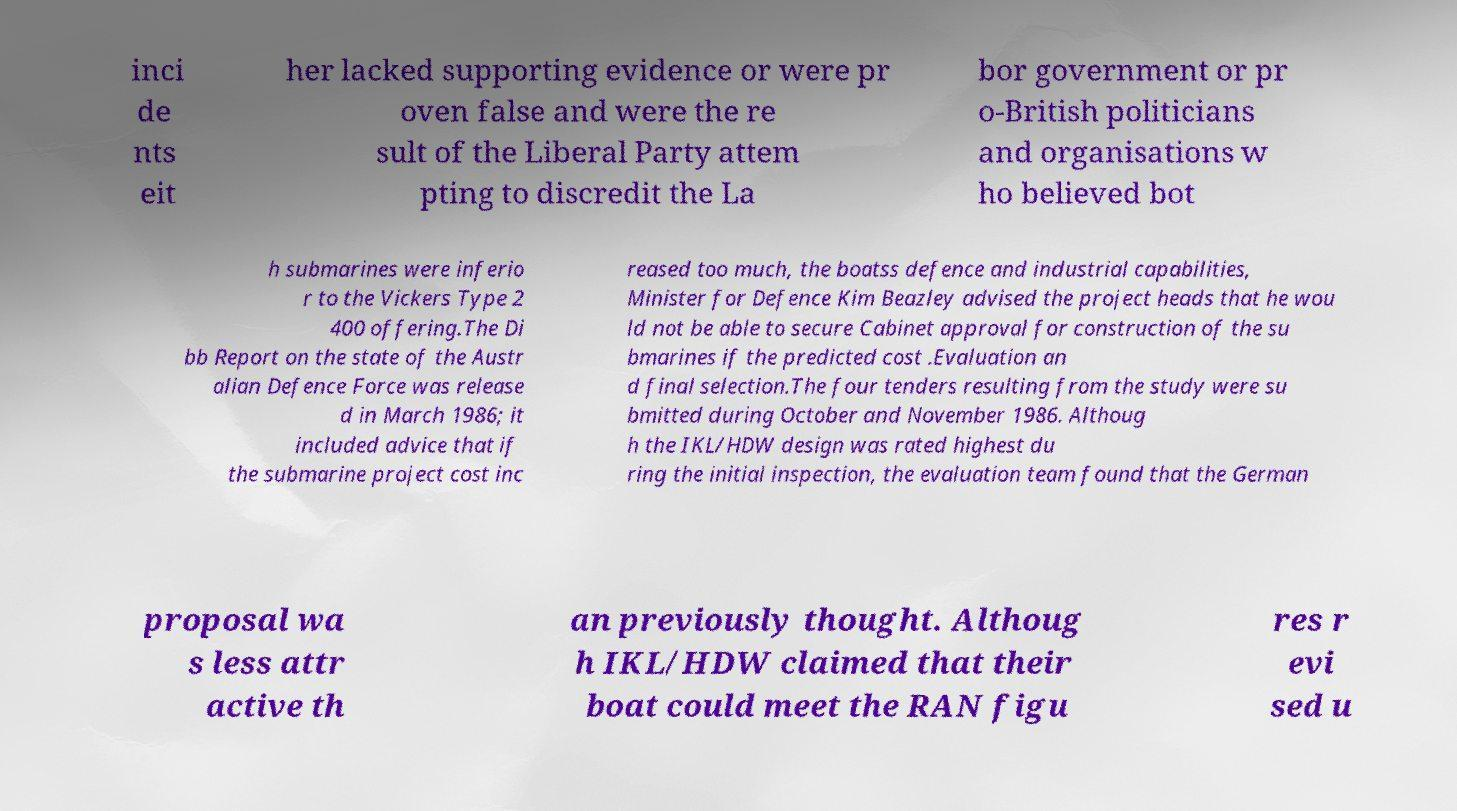Could you assist in decoding the text presented in this image and type it out clearly? inci de nts eit her lacked supporting evidence or were pr oven false and were the re sult of the Liberal Party attem pting to discredit the La bor government or pr o-British politicians and organisations w ho believed bot h submarines were inferio r to the Vickers Type 2 400 offering.The Di bb Report on the state of the Austr alian Defence Force was release d in March 1986; it included advice that if the submarine project cost inc reased too much, the boatss defence and industrial capabilities, Minister for Defence Kim Beazley advised the project heads that he wou ld not be able to secure Cabinet approval for construction of the su bmarines if the predicted cost .Evaluation an d final selection.The four tenders resulting from the study were su bmitted during October and November 1986. Althoug h the IKL/HDW design was rated highest du ring the initial inspection, the evaluation team found that the German proposal wa s less attr active th an previously thought. Althoug h IKL/HDW claimed that their boat could meet the RAN figu res r evi sed u 